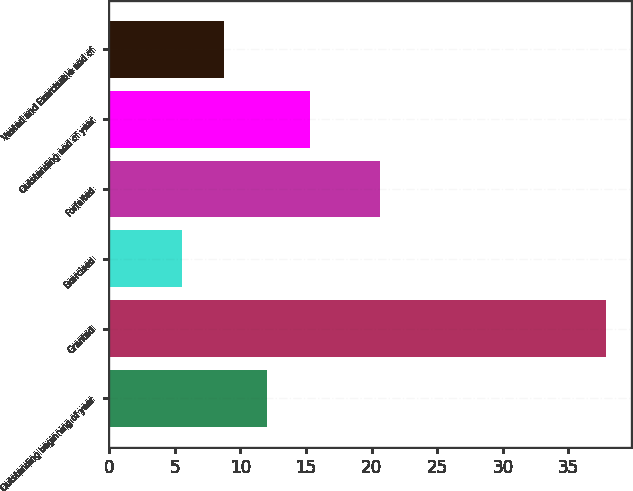Convert chart. <chart><loc_0><loc_0><loc_500><loc_500><bar_chart><fcel>Outstanding beginning of year<fcel>Granted<fcel>Exercised<fcel>Forfeited<fcel>Outstanding end of year<fcel>Vested and Exercisable end of<nl><fcel>12<fcel>37.88<fcel>5.53<fcel>20.66<fcel>15.3<fcel>8.77<nl></chart> 